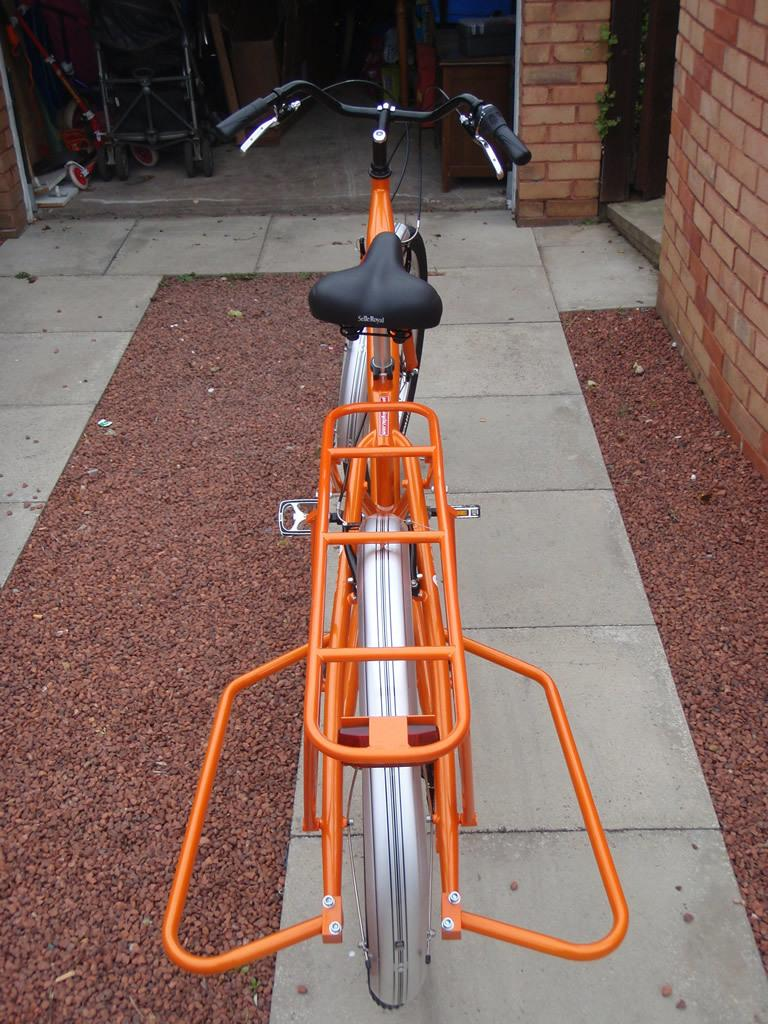What color is the bicycle in the image? The bicycle in the image is orange. How is the bicycle positioned in the image? The bicycle is parked on the floor. What color is the seat of the bicycle? The seat of the bicycle is black. What color is the handle of the bicycle? The handle of the bicycle is black. What can be seen on the right side of the image? There is a wall on the right side of the image. What is the color of the wall in the image? The wall is in brown color. What type of story is being told by the heart-shaped quince on the bicycle? There is no heart-shaped quince present in the image, and therefore no story is being told. 